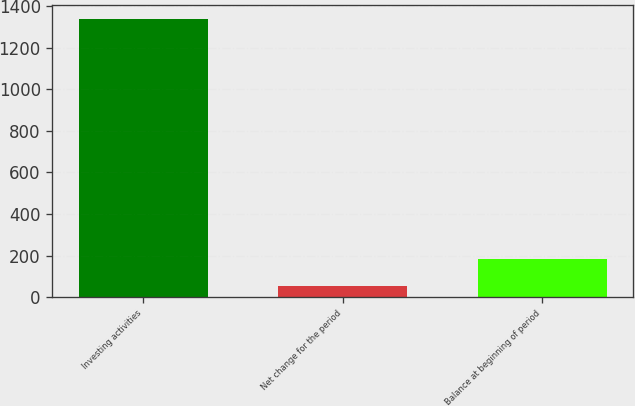Convert chart. <chart><loc_0><loc_0><loc_500><loc_500><bar_chart><fcel>Investing activities<fcel>Net change for the period<fcel>Balance at beginning of period<nl><fcel>1337<fcel>55<fcel>183.2<nl></chart> 